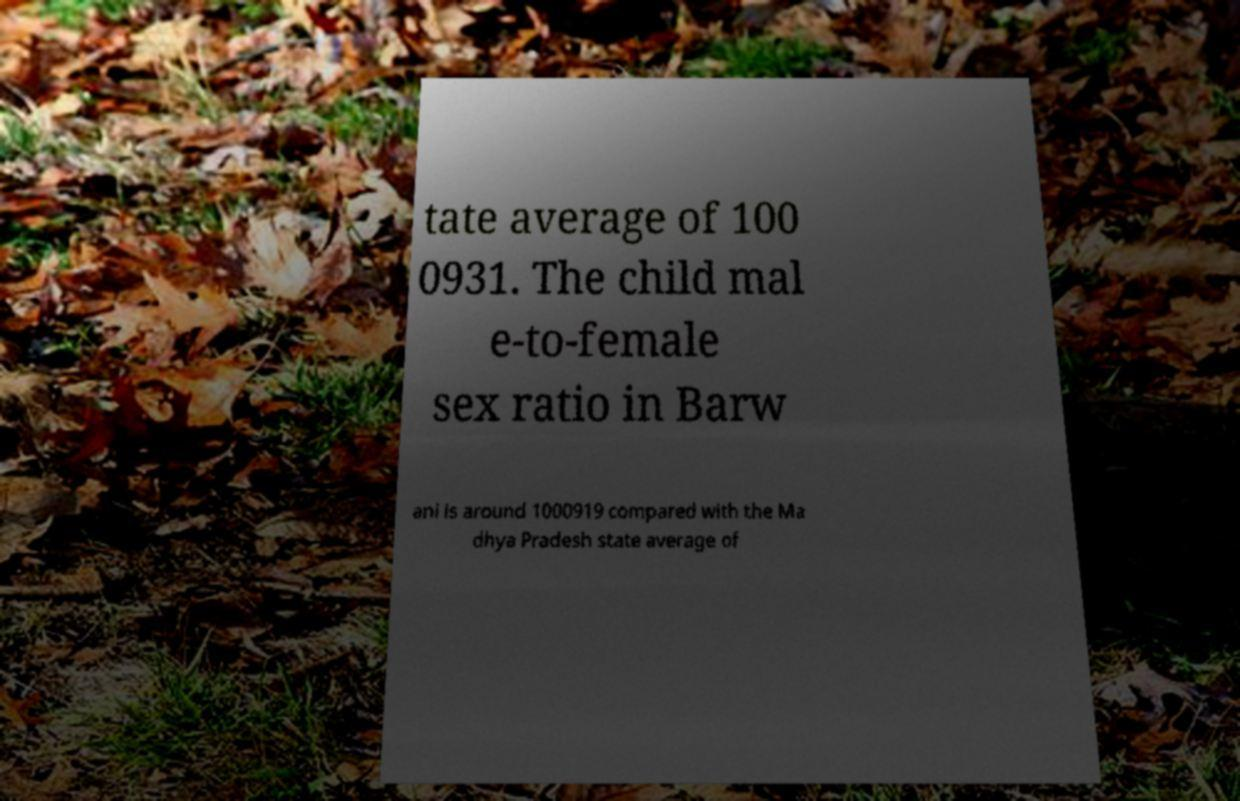Could you extract and type out the text from this image? tate average of 100 0931. The child mal e-to-female sex ratio in Barw ani is around 1000919 compared with the Ma dhya Pradesh state average of 